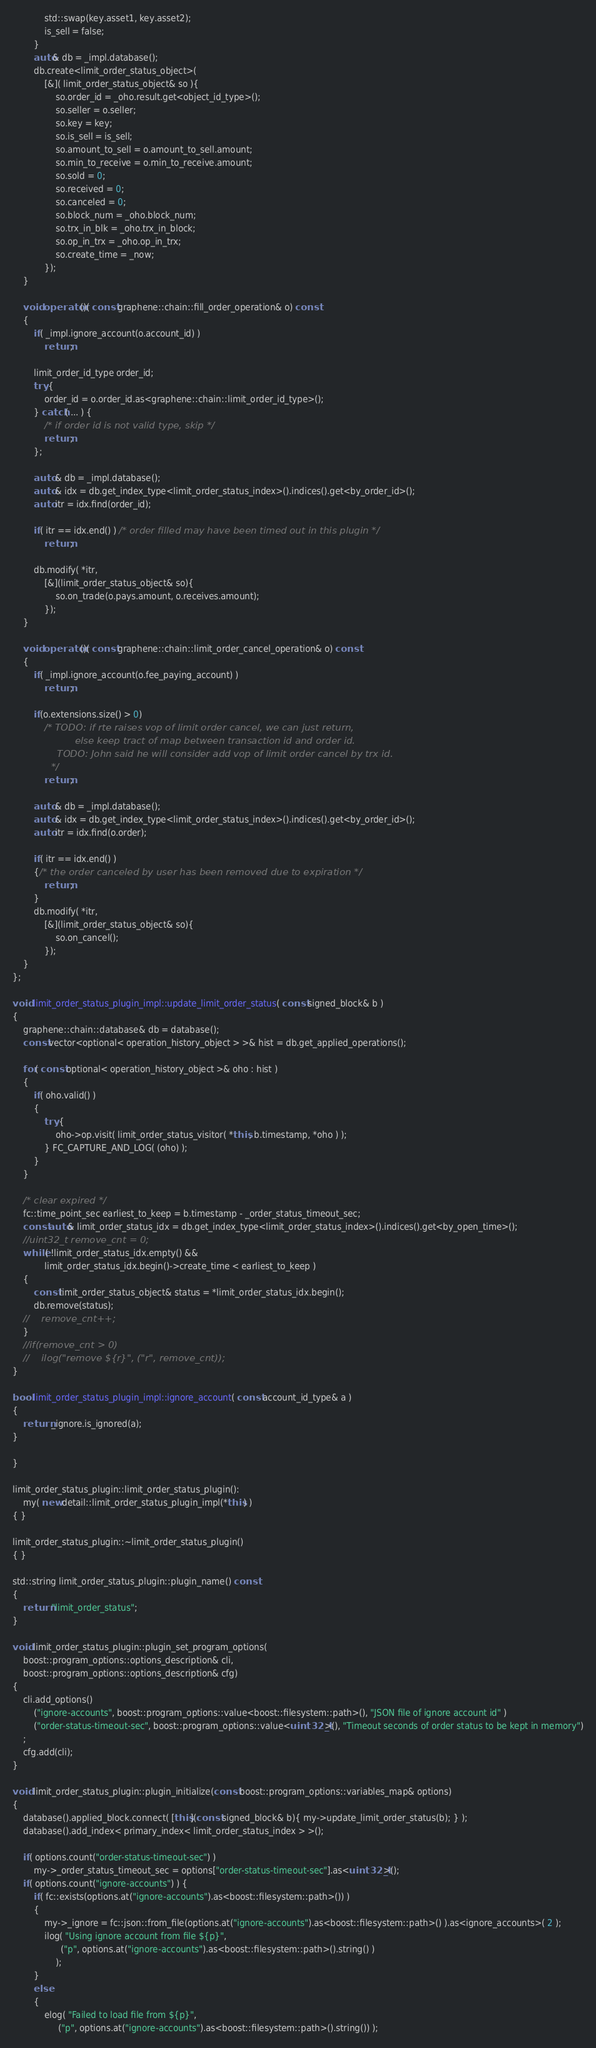Convert code to text. <code><loc_0><loc_0><loc_500><loc_500><_C++_>            std::swap(key.asset1, key.asset2);
            is_sell = false;
        }
        auto& db = _impl.database();
        db.create<limit_order_status_object>(
            [&]( limit_order_status_object& so ){
                so.order_id = _oho.result.get<object_id_type>();
                so.seller = o.seller;
                so.key = key;
                so.is_sell = is_sell;
                so.amount_to_sell = o.amount_to_sell.amount;
                so.min_to_receive = o.min_to_receive.amount;
                so.sold = 0;
                so.received = 0;
                so.canceled = 0;
                so.block_num = _oho.block_num;
                so.trx_in_blk = _oho.trx_in_block;
                so.op_in_trx = _oho.op_in_trx;
                so.create_time = _now;
            });
    }

    void operator()( const graphene::chain::fill_order_operation& o) const
    {
        if( _impl.ignore_account(o.account_id) )
            return;

        limit_order_id_type order_id;
        try {
            order_id = o.order_id.as<graphene::chain::limit_order_id_type>();
        } catch( ... ) {
            /* if order id is not valid type, skip */
            return;
        };

        auto & db = _impl.database();
        auto & idx = db.get_index_type<limit_order_status_index>().indices().get<by_order_id>();
        auto itr = idx.find(order_id);

        if( itr == idx.end() ) /* order filled may have been timed out in this plugin */
            return;
        
        db.modify( *itr,
            [&](limit_order_status_object& so){
                so.on_trade(o.pays.amount, o.receives.amount);
            });
    }

    void operator()( const graphene::chain::limit_order_cancel_operation& o) const
    {
        if( _impl.ignore_account(o.fee_paying_account) )
            return;

        if(o.extensions.size() > 0)
            /* TODO: if rte raises vop of limit order cancel, we can just return,
                     else keep tract of map between transaction id and order id.
               TODO: John said he will consider add vop of limit order cancel by trx id.
             */
            return;

        auto & db = _impl.database();
        auto & idx = db.get_index_type<limit_order_status_index>().indices().get<by_order_id>();
        auto itr = idx.find(o.order);
        
        if( itr == idx.end() )
        {/* the order canceled by user has been removed due to expiration */
            return;
        }
        db.modify( *itr,
            [&](limit_order_status_object& so){
                so.on_cancel();
            });
    }
};

void limit_order_status_plugin_impl::update_limit_order_status( const signed_block& b )
{
    graphene::chain::database& db = database();
    const vector<optional< operation_history_object > >& hist = db.get_applied_operations();

    for( const optional< operation_history_object >& oho : hist )
    {
        if( oho.valid() )
        {
            try {
                oho->op.visit( limit_order_status_visitor( *this, b.timestamp, *oho ) );
            } FC_CAPTURE_AND_LOG( (oho) );
        }
    }

    /* clear expired */
    fc::time_point_sec earliest_to_keep = b.timestamp - _order_status_timeout_sec;
    const auto& limit_order_status_idx = db.get_index_type<limit_order_status_index>().indices().get<by_open_time>();
    //uint32_t remove_cnt = 0;
    while( !limit_order_status_idx.empty() &&
            limit_order_status_idx.begin()->create_time < earliest_to_keep )
    {
        const limit_order_status_object& status = *limit_order_status_idx.begin();
        db.remove(status);
    //    remove_cnt++;
    }
    //if(remove_cnt > 0)
    //    ilog("remove ${r}", ("r", remove_cnt));
}

bool limit_order_status_plugin_impl::ignore_account( const account_id_type& a )
{
    return _ignore.is_ignored(a);
}

}

limit_order_status_plugin::limit_order_status_plugin():
    my( new detail::limit_order_status_plugin_impl(*this) )
{ }

limit_order_status_plugin::~limit_order_status_plugin()
{ }

std::string limit_order_status_plugin::plugin_name() const
{
    return "limit_order_status";
}

void limit_order_status_plugin::plugin_set_program_options(
    boost::program_options::options_description& cli,
    boost::program_options::options_description& cfg)
{
    cli.add_options()
        ("ignore-accounts", boost::program_options::value<boost::filesystem::path>(), "JSON file of ignore account id" )
        ("order-status-timeout-sec", boost::program_options::value<uint32_t>(), "Timeout seconds of order status to be kept in memory")
    ;
    cfg.add(cli);
}

void limit_order_status_plugin::plugin_initialize(const boost::program_options::variables_map& options)
{
    database().applied_block.connect( [this](const signed_block& b){ my->update_limit_order_status(b); } );
    database().add_index< primary_index< limit_order_status_index > >(); 

    if( options.count("order-status-timeout-sec") )
        my->_order_status_timeout_sec = options["order-status-timeout-sec"].as<uint32_t>();
    if( options.count("ignore-accounts") ) {
        if( fc::exists(options.at("ignore-accounts").as<boost::filesystem::path>()) )
        {
            my->_ignore = fc::json::from_file(options.at("ignore-accounts").as<boost::filesystem::path>() ).as<ignore_accounts>( 2 );
            ilog( "Using ignore account from file ${p}",
                  ("p", options.at("ignore-accounts").as<boost::filesystem::path>().string() )
                );
        }
        else
        {
            elog( "Failed to load file from ${p}",
                 ("p", options.at("ignore-accounts").as<boost::filesystem::path>().string()) );</code> 